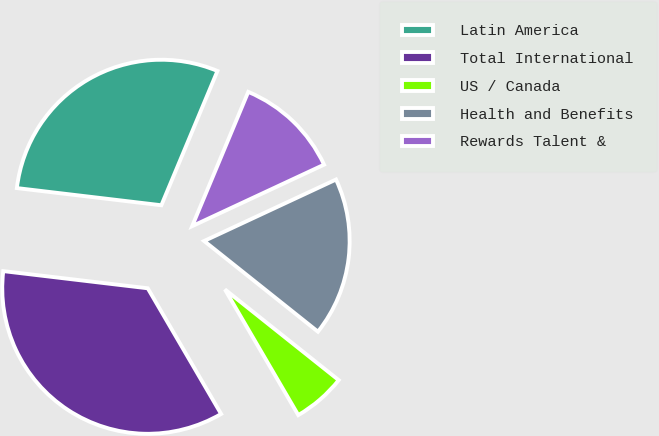Convert chart to OTSL. <chart><loc_0><loc_0><loc_500><loc_500><pie_chart><fcel>Latin America<fcel>Total International<fcel>US / Canada<fcel>Health and Benefits<fcel>Rewards Talent &<nl><fcel>29.41%<fcel>35.29%<fcel>5.88%<fcel>17.65%<fcel>11.76%<nl></chart> 